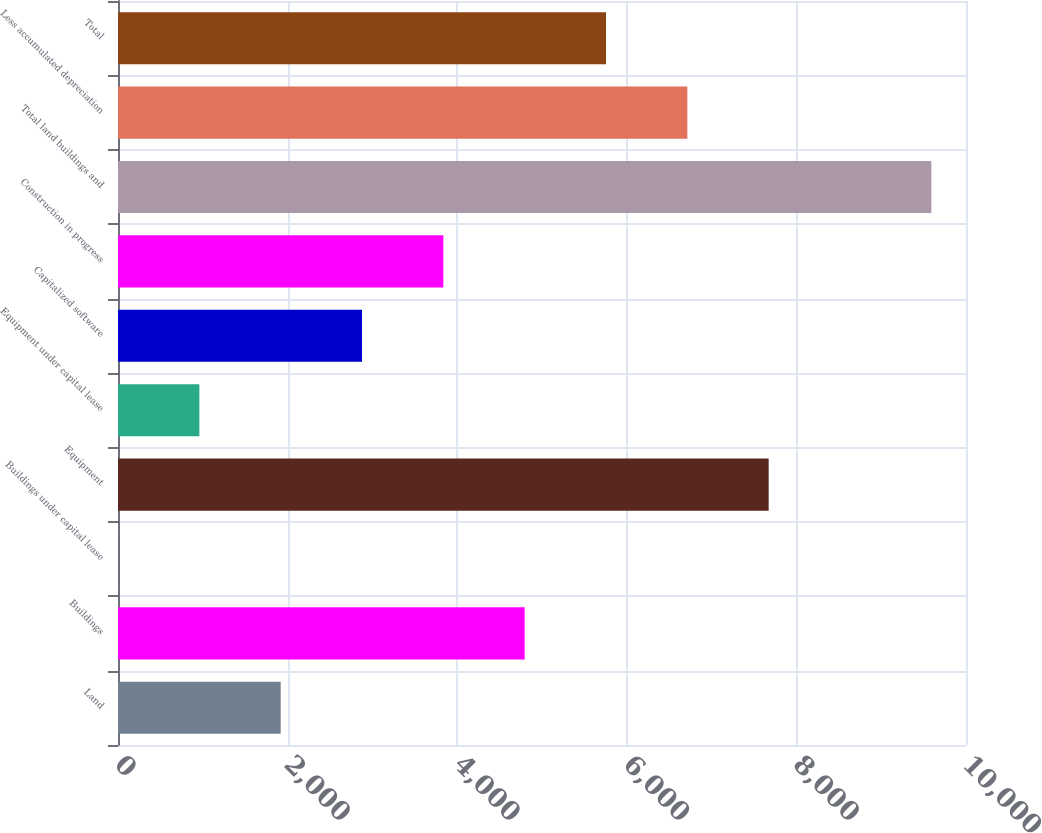Convert chart to OTSL. <chart><loc_0><loc_0><loc_500><loc_500><bar_chart><fcel>Land<fcel>Buildings<fcel>Buildings under capital lease<fcel>Equipment<fcel>Equipment under capital lease<fcel>Capitalized software<fcel>Construction in progress<fcel>Total land buildings and<fcel>Less accumulated depreciation<fcel>Total<nl><fcel>1918.46<fcel>4795.7<fcel>0.3<fcel>7672.94<fcel>959.38<fcel>2877.54<fcel>3836.62<fcel>9591.1<fcel>6713.86<fcel>5754.78<nl></chart> 